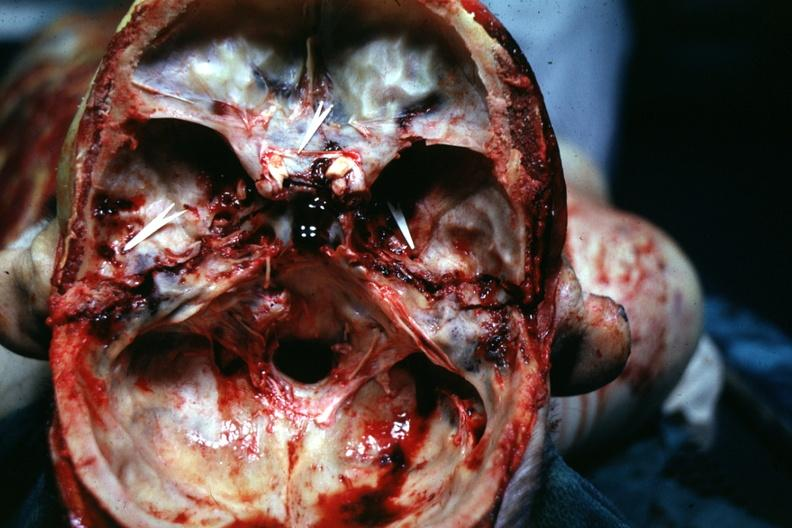what is present?
Answer the question using a single word or phrase. Bone 